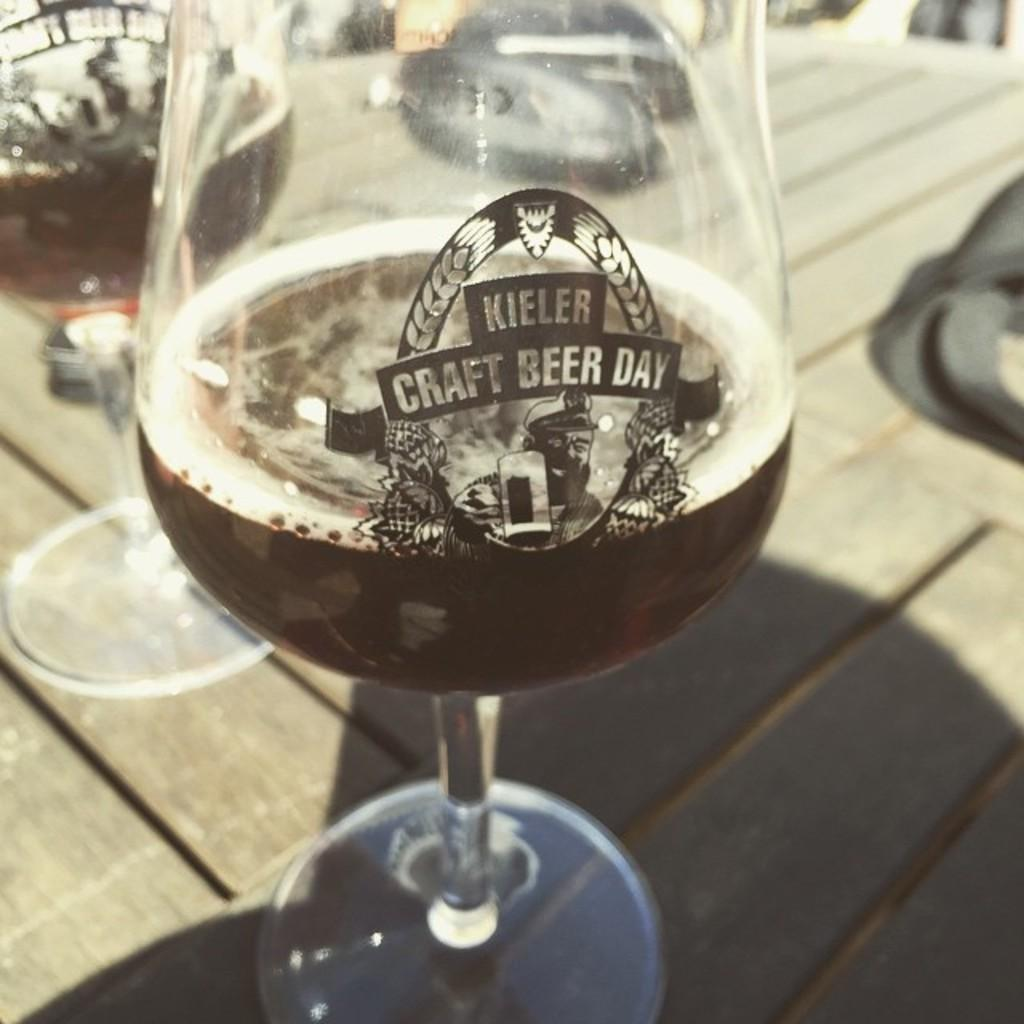What can be seen in the glasses in the image? There are drinks in the glasses in the image. Where are the glasses located? The glasses are on a platform in the image. What type of curve can be seen in the image? There is no curve present in the image. Is there a rifle visible in the image? No, there is no rifle present in the image. 